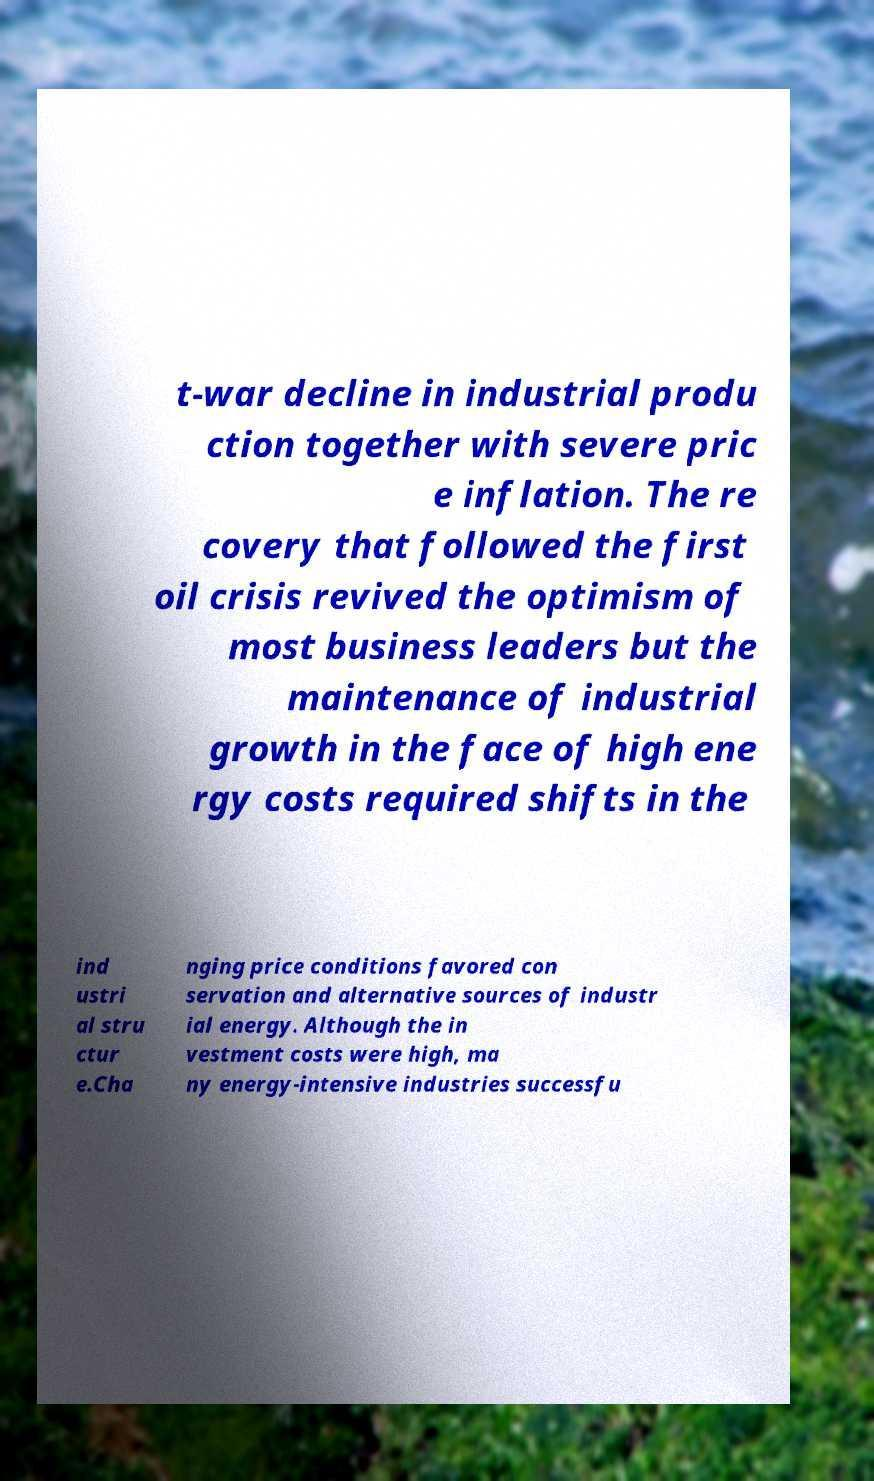There's text embedded in this image that I need extracted. Can you transcribe it verbatim? t-war decline in industrial produ ction together with severe pric e inflation. The re covery that followed the first oil crisis revived the optimism of most business leaders but the maintenance of industrial growth in the face of high ene rgy costs required shifts in the ind ustri al stru ctur e.Cha nging price conditions favored con servation and alternative sources of industr ial energy. Although the in vestment costs were high, ma ny energy-intensive industries successfu 